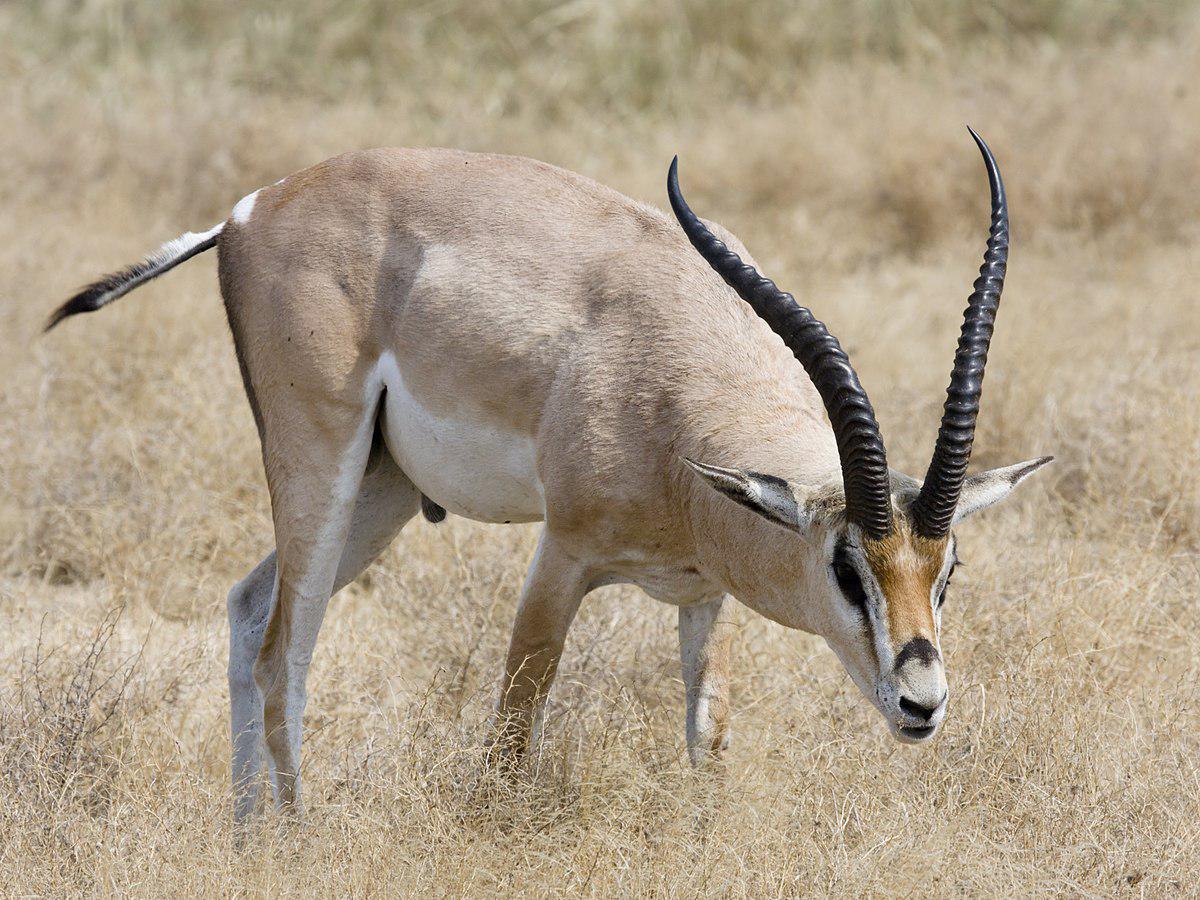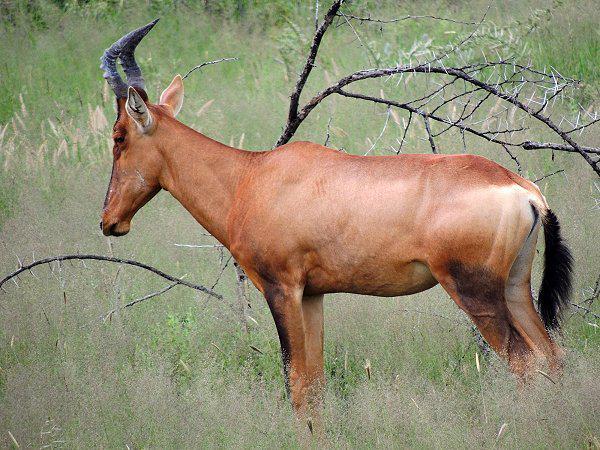The first image is the image on the left, the second image is the image on the right. Evaluate the accuracy of this statement regarding the images: "There is a total of 1 gazelle laying on the ground.". Is it true? Answer yes or no. No. The first image is the image on the left, the second image is the image on the right. For the images displayed, is the sentence "You can see a second animal further off in the background." factually correct? Answer yes or no. No. 